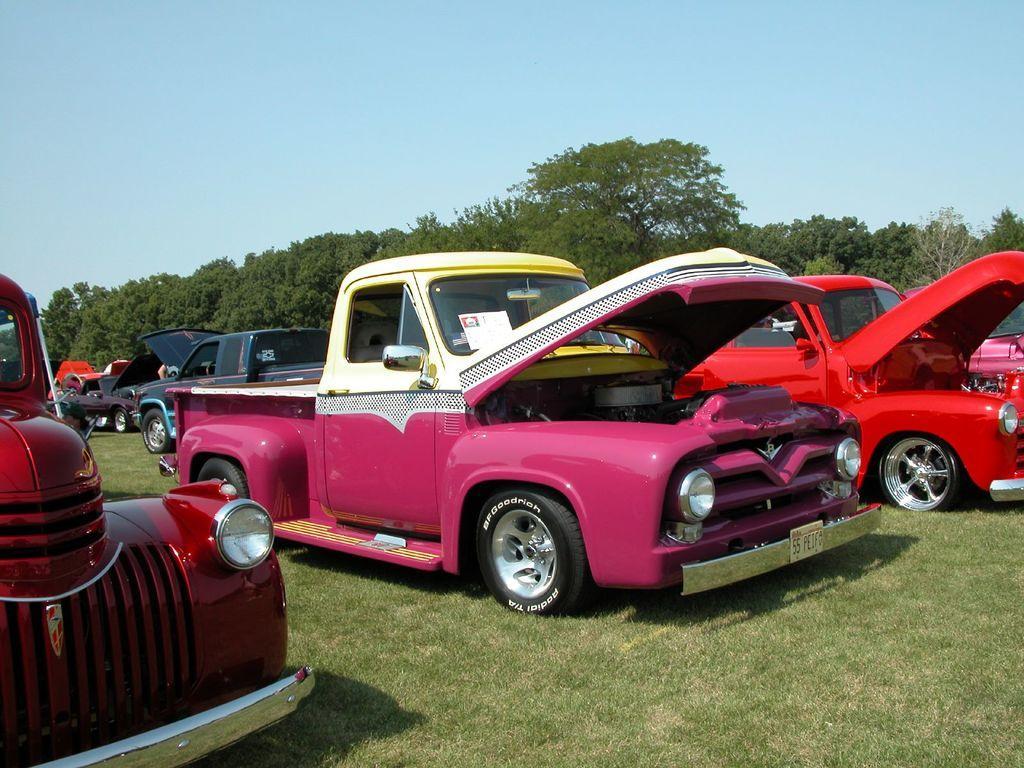Describe this image in one or two sentences. In this image I can see colorful cars parked on the grass. There are trees at the back. 